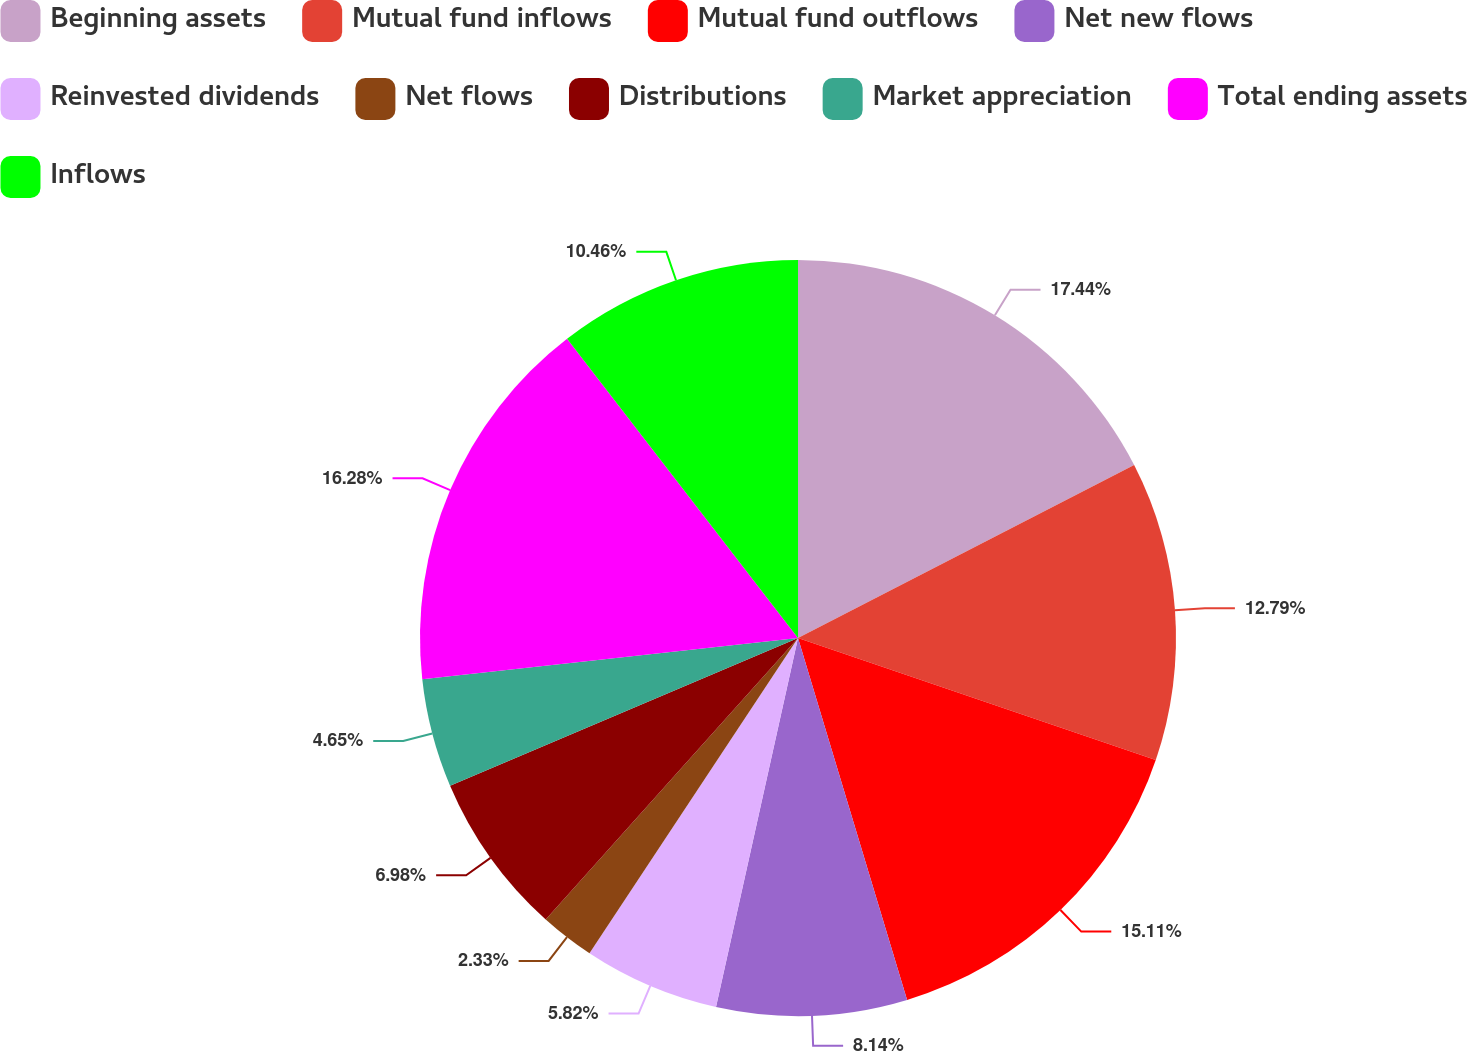Convert chart. <chart><loc_0><loc_0><loc_500><loc_500><pie_chart><fcel>Beginning assets<fcel>Mutual fund inflows<fcel>Mutual fund outflows<fcel>Net new flows<fcel>Reinvested dividends<fcel>Net flows<fcel>Distributions<fcel>Market appreciation<fcel>Total ending assets<fcel>Inflows<nl><fcel>17.44%<fcel>12.79%<fcel>15.11%<fcel>8.14%<fcel>5.82%<fcel>2.33%<fcel>6.98%<fcel>4.65%<fcel>16.28%<fcel>10.46%<nl></chart> 